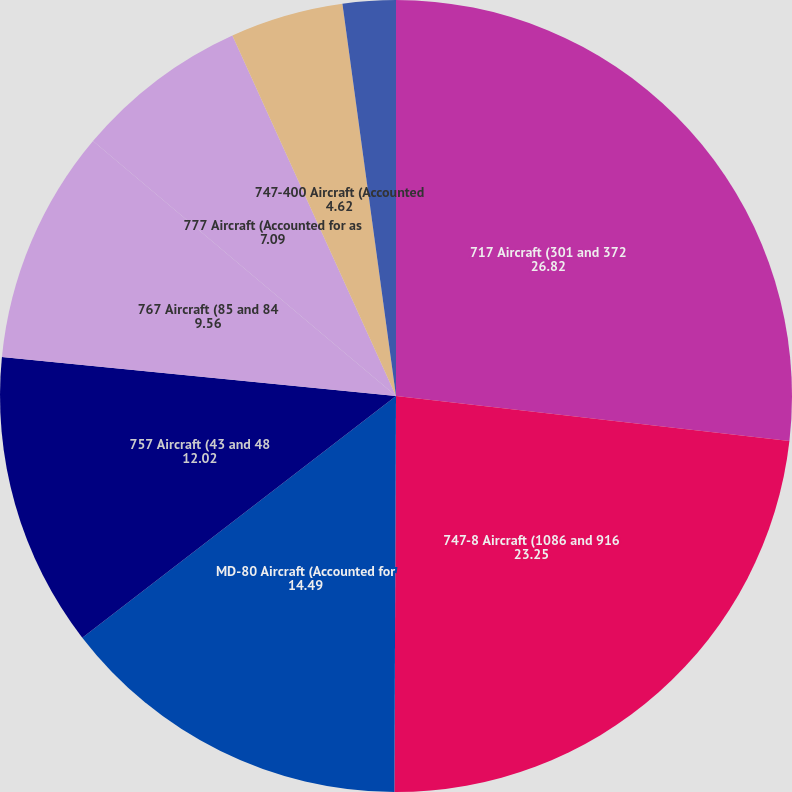Convert chart to OTSL. <chart><loc_0><loc_0><loc_500><loc_500><pie_chart><fcel>717 Aircraft (301 and 372<fcel>747-8 Aircraft (1086 and 916<fcel>MD-80 Aircraft (Accounted for<fcel>757 Aircraft (43 and 48<fcel>767 Aircraft (85 and 84<fcel>777 Aircraft (Accounted for as<fcel>747-400 Aircraft (Accounted<fcel>737 Aircraft (Accounted for as<nl><fcel>26.82%<fcel>23.25%<fcel>14.49%<fcel>12.02%<fcel>9.56%<fcel>7.09%<fcel>4.62%<fcel>2.16%<nl></chart> 